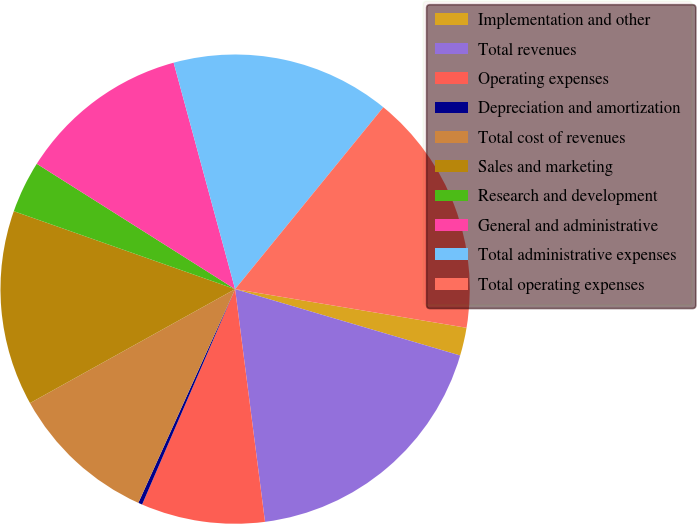Convert chart to OTSL. <chart><loc_0><loc_0><loc_500><loc_500><pie_chart><fcel>Implementation and other<fcel>Total revenues<fcel>Operating expenses<fcel>Depreciation and amortization<fcel>Total cost of revenues<fcel>Sales and marketing<fcel>Research and development<fcel>General and administrative<fcel>Total administrative expenses<fcel>Total operating expenses<nl><fcel>1.93%<fcel>18.4%<fcel>8.52%<fcel>0.28%<fcel>10.16%<fcel>13.46%<fcel>3.58%<fcel>11.81%<fcel>15.1%<fcel>16.75%<nl></chart> 